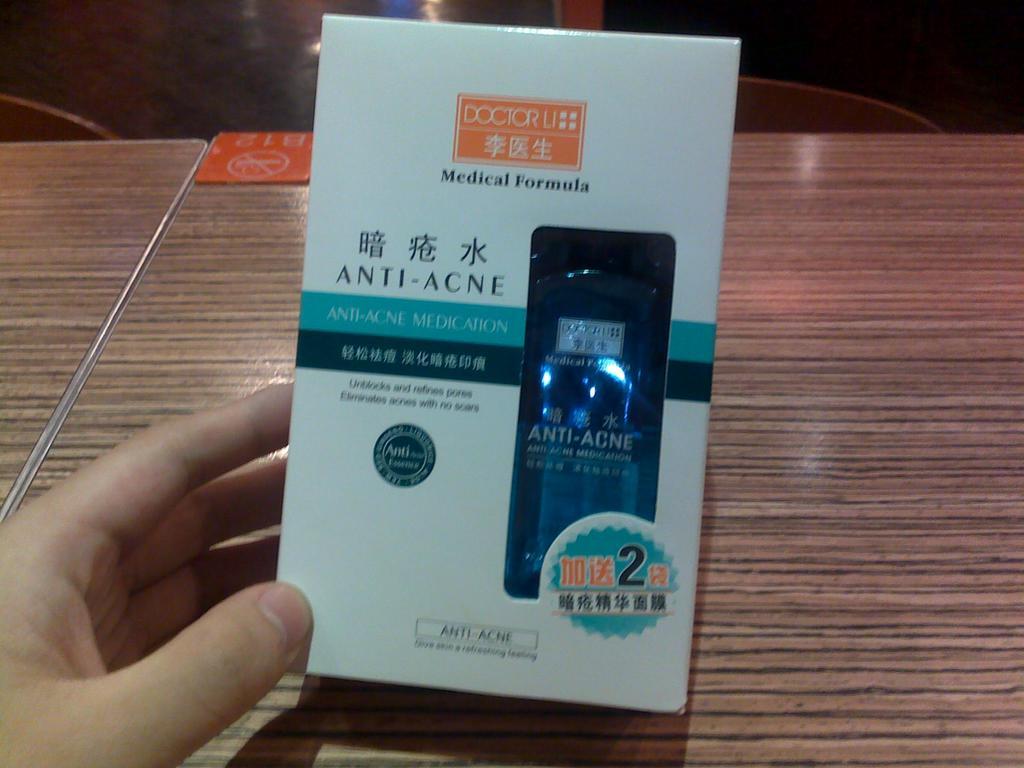What is this product?
Keep it short and to the point. Anti-acne. What is the number in the stamp at the bottom right?
Ensure brevity in your answer.  2. 